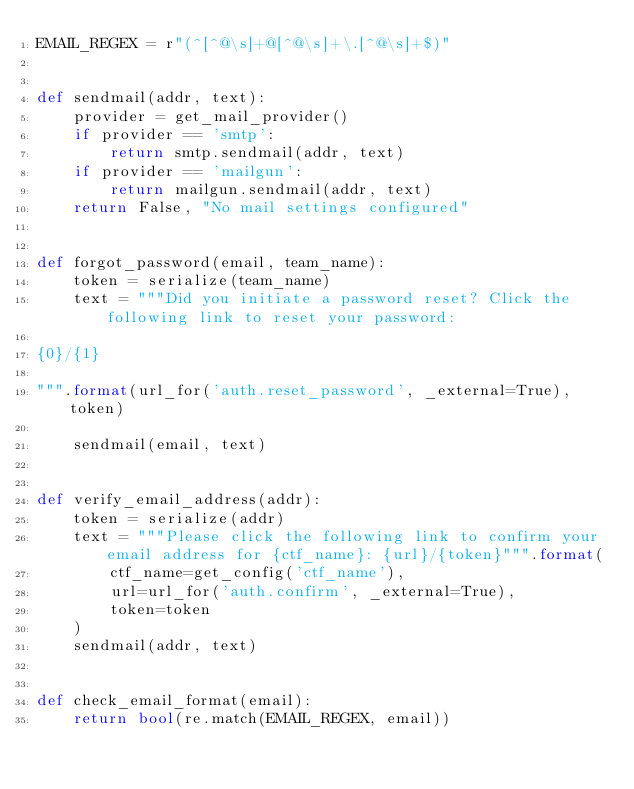Convert code to text. <code><loc_0><loc_0><loc_500><loc_500><_Python_>EMAIL_REGEX = r"(^[^@\s]+@[^@\s]+\.[^@\s]+$)"


def sendmail(addr, text):
    provider = get_mail_provider()
    if provider == 'smtp':
        return smtp.sendmail(addr, text)
    if provider == 'mailgun':
        return mailgun.sendmail(addr, text)
    return False, "No mail settings configured"


def forgot_password(email, team_name):
    token = serialize(team_name)
    text = """Did you initiate a password reset? Click the following link to reset your password:

{0}/{1}

""".format(url_for('auth.reset_password', _external=True), token)

    sendmail(email, text)


def verify_email_address(addr):
    token = serialize(addr)
    text = """Please click the following link to confirm your email address for {ctf_name}: {url}/{token}""".format(
        ctf_name=get_config('ctf_name'),
        url=url_for('auth.confirm', _external=True),
        token=token
    )
    sendmail(addr, text)


def check_email_format(email):
    return bool(re.match(EMAIL_REGEX, email))
</code> 